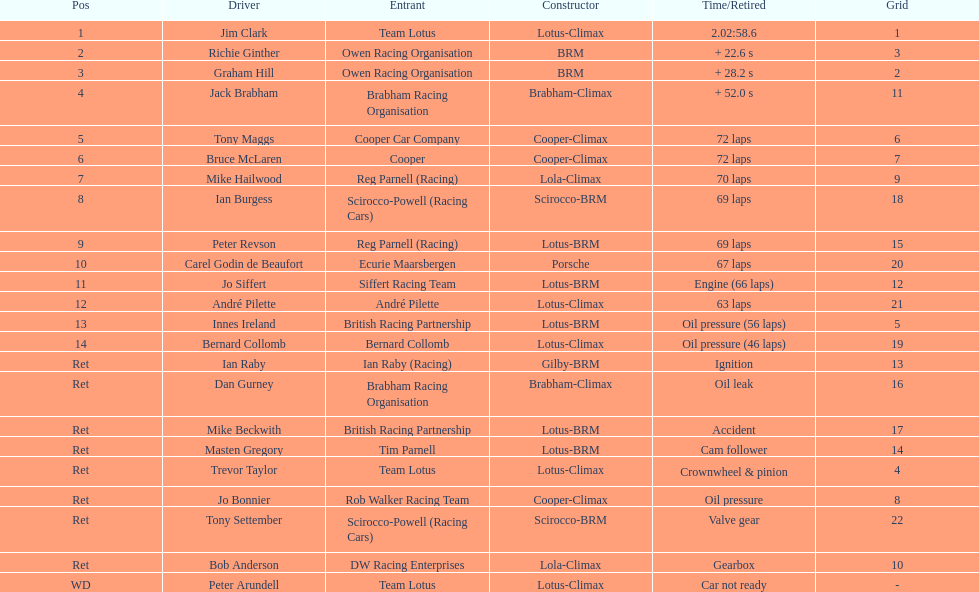Who are all the participants? Jim Clark, Richie Ginther, Graham Hill, Jack Brabham, Tony Maggs, Bruce McLaren, Mike Hailwood, Ian Burgess, Peter Revson, Carel Godin de Beaufort, Jo Siffert, André Pilette, Innes Ireland, Bernard Collomb, Ian Raby, Dan Gurney, Mike Beckwith, Masten Gregory, Trevor Taylor, Jo Bonnier, Tony Settember, Bob Anderson, Peter Arundell. What ranking did they achieve? 1, 2, 3, 4, 5, 6, 7, 8, 9, 10, 11, 12, 13, 14, Ret, Ret, Ret, Ret, Ret, Ret, Ret, Ret, WD. What about specifically tony maggs and jo siffert? 5, 11. And among them, which racer finished earlier? Tony Maggs. 